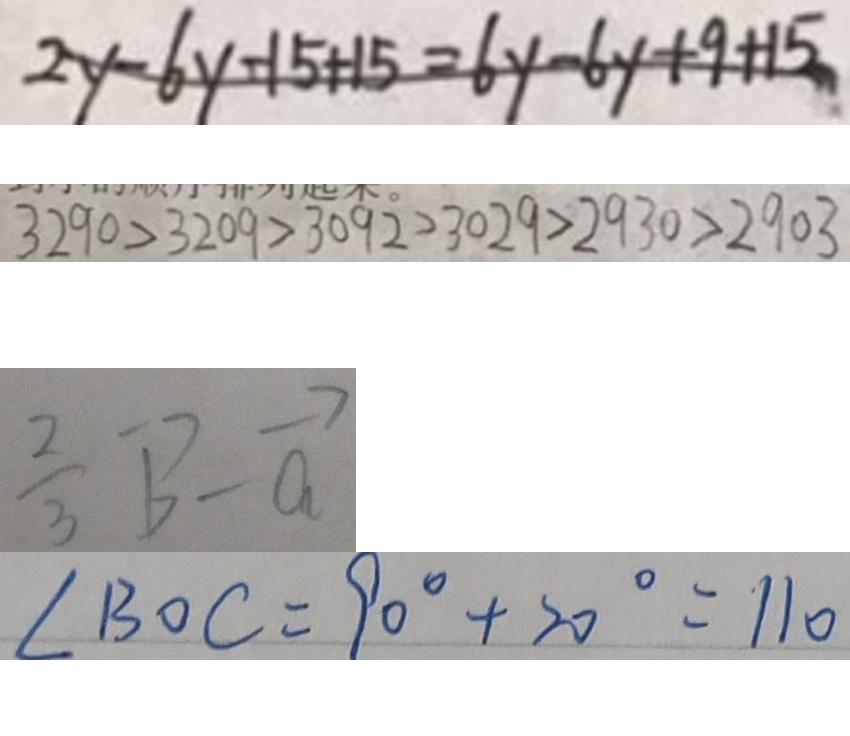Convert formula to latex. <formula><loc_0><loc_0><loc_500><loc_500>2 y - 6 y - 1 5 + 1 5 = 6 y - 6 y + 9 + 1 5 
 3 2 9 0 > 3 2 0 9 > 3 0 9 \dot { 2 } > 3 0 2 9 > 2 9 3 0 > 2 9 0 3 
 \frac { 2 } { 3 } \overrightarrow { b } - \overrightarrow { a } 
 \angle B O C = 9 0 ^ { \circ } + 2 0 ^ { \circ } = 1 1 0</formula> 